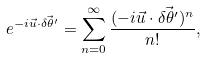<formula> <loc_0><loc_0><loc_500><loc_500>e ^ { - i \vec { u } \cdot \vec { \delta \theta ^ { \prime } } } = \sum _ { n = 0 } ^ { \infty } { \frac { ( - i \vec { u } \cdot \vec { \delta \theta ^ { \prime } } ) ^ { n } } { n ! } } ,</formula> 